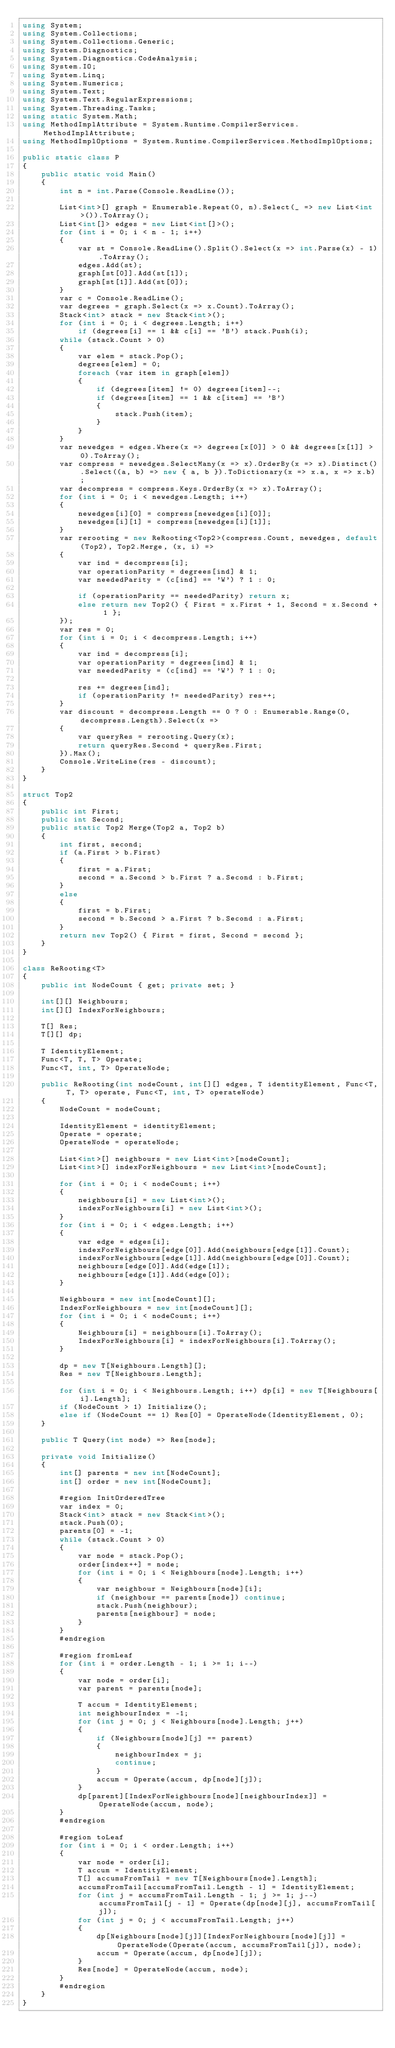Convert code to text. <code><loc_0><loc_0><loc_500><loc_500><_C#_>using System;
using System.Collections;
using System.Collections.Generic;
using System.Diagnostics;
using System.Diagnostics.CodeAnalysis;
using System.IO;
using System.Linq;
using System.Numerics;
using System.Text;
using System.Text.RegularExpressions;
using System.Threading.Tasks;
using static System.Math;
using MethodImplAttribute = System.Runtime.CompilerServices.MethodImplAttribute;
using MethodImplOptions = System.Runtime.CompilerServices.MethodImplOptions;

public static class P
{
    public static void Main()
    {
        int n = int.Parse(Console.ReadLine());

        List<int>[] graph = Enumerable.Repeat(0, n).Select(_ => new List<int>()).ToArray();
        List<int[]> edges = new List<int[]>();
        for (int i = 0; i < n - 1; i++)
        {
            var st = Console.ReadLine().Split().Select(x => int.Parse(x) - 1).ToArray();
            edges.Add(st);
            graph[st[0]].Add(st[1]);
            graph[st[1]].Add(st[0]);
        }
        var c = Console.ReadLine();
        var degrees = graph.Select(x => x.Count).ToArray();
        Stack<int> stack = new Stack<int>();
        for (int i = 0; i < degrees.Length; i++)
            if (degrees[i] == 1 && c[i] == 'B') stack.Push(i);
        while (stack.Count > 0)
        {
            var elem = stack.Pop();
            degrees[elem] = 0;
            foreach (var item in graph[elem])
            {
                if (degrees[item] != 0) degrees[item]--;
                if (degrees[item] == 1 && c[item] == 'B')
                {
                    stack.Push(item);
                }
            }
        }
        var newedges = edges.Where(x => degrees[x[0]] > 0 && degrees[x[1]] > 0).ToArray();
        var compress = newedges.SelectMany(x => x).OrderBy(x => x).Distinct().Select((a, b) => new { a, b }).ToDictionary(x => x.a, x => x.b);
        var decompress = compress.Keys.OrderBy(x => x).ToArray();
        for (int i = 0; i < newedges.Length; i++)
        {
            newedges[i][0] = compress[newedges[i][0]];
            newedges[i][1] = compress[newedges[i][1]];
        }
        var rerooting = new ReRooting<Top2>(compress.Count, newedges, default(Top2), Top2.Merge, (x, i) =>
        {
            var ind = decompress[i];
            var operationParity = degrees[ind] & 1;
            var neededParity = (c[ind] == 'W') ? 1 : 0;

            if (operationParity == neededParity) return x;
            else return new Top2() { First = x.First + 1, Second = x.Second + 1 };
        });
        var res = 0;
        for (int i = 0; i < decompress.Length; i++)
        {
            var ind = decompress[i];
            var operationParity = degrees[ind] & 1;
            var neededParity = (c[ind] == 'W') ? 1 : 0;

            res += degrees[ind];
            if (operationParity != neededParity) res++;
        }
        var discount = decompress.Length == 0 ? 0 : Enumerable.Range(0, decompress.Length).Select(x =>
        {
            var queryRes = rerooting.Query(x);
            return queryRes.Second + queryRes.First;
        }).Max();
        Console.WriteLine(res - discount);
    }
}

struct Top2
{
    public int First;
    public int Second;
    public static Top2 Merge(Top2 a, Top2 b)
    {
        int first, second;
        if (a.First > b.First)
        {
            first = a.First;
            second = a.Second > b.First ? a.Second : b.First;
        }
        else
        {
            first = b.First;
            second = b.Second > a.First ? b.Second : a.First;
        }
        return new Top2() { First = first, Second = second };
    }
}

class ReRooting<T>
{
    public int NodeCount { get; private set; }

    int[][] Neighbours;
    int[][] IndexForNeighbours;

    T[] Res;
    T[][] dp;

    T IdentityElement;
    Func<T, T, T> Operate;
    Func<T, int, T> OperateNode;

    public ReRooting(int nodeCount, int[][] edges, T identityElement, Func<T, T, T> operate, Func<T, int, T> operateNode)
    {
        NodeCount = nodeCount;

        IdentityElement = identityElement;
        Operate = operate;
        OperateNode = operateNode;

        List<int>[] neighbours = new List<int>[nodeCount];
        List<int>[] indexForNeighbours = new List<int>[nodeCount];

        for (int i = 0; i < nodeCount; i++)
        {
            neighbours[i] = new List<int>();
            indexForNeighbours[i] = new List<int>();
        }
        for (int i = 0; i < edges.Length; i++)
        {
            var edge = edges[i];
            indexForNeighbours[edge[0]].Add(neighbours[edge[1]].Count);
            indexForNeighbours[edge[1]].Add(neighbours[edge[0]].Count);
            neighbours[edge[0]].Add(edge[1]);
            neighbours[edge[1]].Add(edge[0]);
        }

        Neighbours = new int[nodeCount][];
        IndexForNeighbours = new int[nodeCount][];
        for (int i = 0; i < nodeCount; i++)
        {
            Neighbours[i] = neighbours[i].ToArray();
            IndexForNeighbours[i] = indexForNeighbours[i].ToArray();
        }

        dp = new T[Neighbours.Length][];
        Res = new T[Neighbours.Length];

        for (int i = 0; i < Neighbours.Length; i++) dp[i] = new T[Neighbours[i].Length];
        if (NodeCount > 1) Initialize();
        else if (NodeCount == 1) Res[0] = OperateNode(IdentityElement, 0);
    }

    public T Query(int node) => Res[node];

    private void Initialize()
    {
        int[] parents = new int[NodeCount];
        int[] order = new int[NodeCount];

        #region InitOrderedTree
        var index = 0;
        Stack<int> stack = new Stack<int>();
        stack.Push(0);
        parents[0] = -1;
        while (stack.Count > 0)
        {
            var node = stack.Pop();
            order[index++] = node;
            for (int i = 0; i < Neighbours[node].Length; i++)
            {
                var neighbour = Neighbours[node][i];
                if (neighbour == parents[node]) continue;
                stack.Push(neighbour);
                parents[neighbour] = node;
            }
        }
        #endregion

        #region fromLeaf
        for (int i = order.Length - 1; i >= 1; i--)
        {
            var node = order[i];
            var parent = parents[node];

            T accum = IdentityElement;
            int neighbourIndex = -1;
            for (int j = 0; j < Neighbours[node].Length; j++)
            {
                if (Neighbours[node][j] == parent)
                {
                    neighbourIndex = j;
                    continue;
                }
                accum = Operate(accum, dp[node][j]);
            }
            dp[parent][IndexForNeighbours[node][neighbourIndex]] = OperateNode(accum, node);
        }
        #endregion

        #region toLeaf
        for (int i = 0; i < order.Length; i++)
        {
            var node = order[i];
            T accum = IdentityElement;
            T[] accumsFromTail = new T[Neighbours[node].Length];
            accumsFromTail[accumsFromTail.Length - 1] = IdentityElement;
            for (int j = accumsFromTail.Length - 1; j >= 1; j--) accumsFromTail[j - 1] = Operate(dp[node][j], accumsFromTail[j]);
            for (int j = 0; j < accumsFromTail.Length; j++)
            {
                dp[Neighbours[node][j]][IndexForNeighbours[node][j]] = OperateNode(Operate(accum, accumsFromTail[j]), node);
                accum = Operate(accum, dp[node][j]);
            }
            Res[node] = OperateNode(accum, node);
        }
        #endregion
    }
}
</code> 